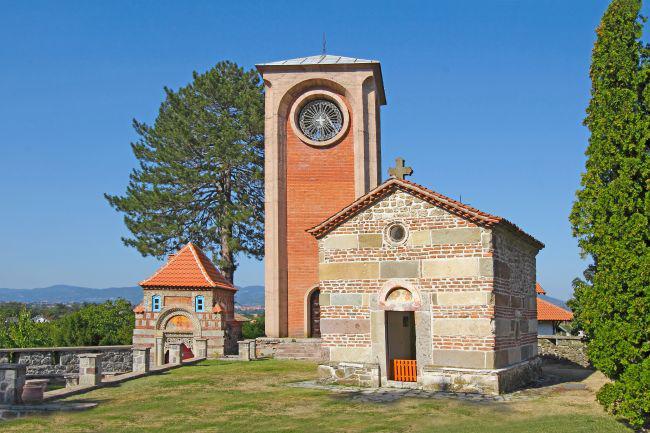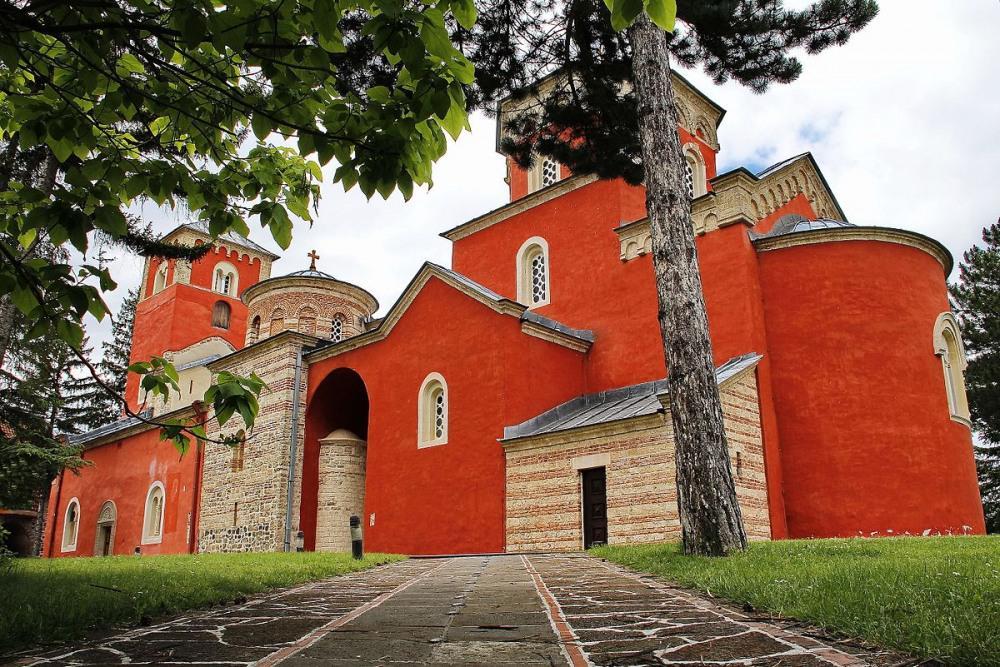The first image is the image on the left, the second image is the image on the right. Analyze the images presented: Is the assertion "Left image shows a reddish-orange building with a dome-topped tower with flat sides featuring round-topped windows." valid? Answer yes or no. No. 